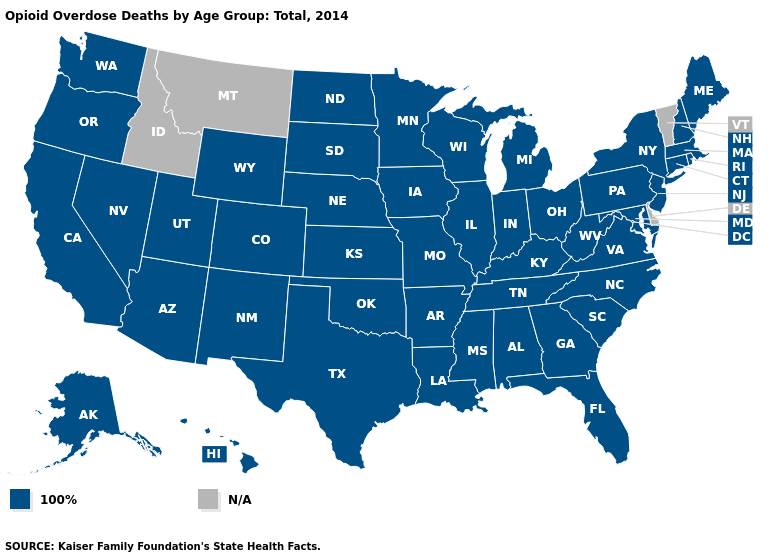What is the value of Louisiana?
Write a very short answer. 100%. Name the states that have a value in the range N/A?
Answer briefly. Delaware, Idaho, Montana, Vermont. Name the states that have a value in the range N/A?
Short answer required. Delaware, Idaho, Montana, Vermont. Among the states that border Mississippi , which have the lowest value?
Quick response, please. Alabama, Arkansas, Louisiana, Tennessee. Which states hav the highest value in the West?
Short answer required. Alaska, Arizona, California, Colorado, Hawaii, Nevada, New Mexico, Oregon, Utah, Washington, Wyoming. Does the first symbol in the legend represent the smallest category?
Keep it brief. Yes. What is the value of Kentucky?
Answer briefly. 100%. What is the value of Maryland?
Write a very short answer. 100%. What is the value of Connecticut?
Give a very brief answer. 100%. Which states have the lowest value in the Northeast?
Answer briefly. Connecticut, Maine, Massachusetts, New Hampshire, New Jersey, New York, Pennsylvania, Rhode Island. What is the value of Utah?
Quick response, please. 100%. What is the highest value in the West ?
Quick response, please. 100%. Name the states that have a value in the range 100%?
Answer briefly. Alabama, Alaska, Arizona, Arkansas, California, Colorado, Connecticut, Florida, Georgia, Hawaii, Illinois, Indiana, Iowa, Kansas, Kentucky, Louisiana, Maine, Maryland, Massachusetts, Michigan, Minnesota, Mississippi, Missouri, Nebraska, Nevada, New Hampshire, New Jersey, New Mexico, New York, North Carolina, North Dakota, Ohio, Oklahoma, Oregon, Pennsylvania, Rhode Island, South Carolina, South Dakota, Tennessee, Texas, Utah, Virginia, Washington, West Virginia, Wisconsin, Wyoming. 